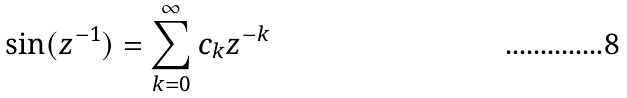Convert formula to latex. <formula><loc_0><loc_0><loc_500><loc_500>\sin ( z ^ { - 1 } ) = \sum _ { k = 0 } ^ { \infty } c _ { k } z ^ { - k }</formula> 